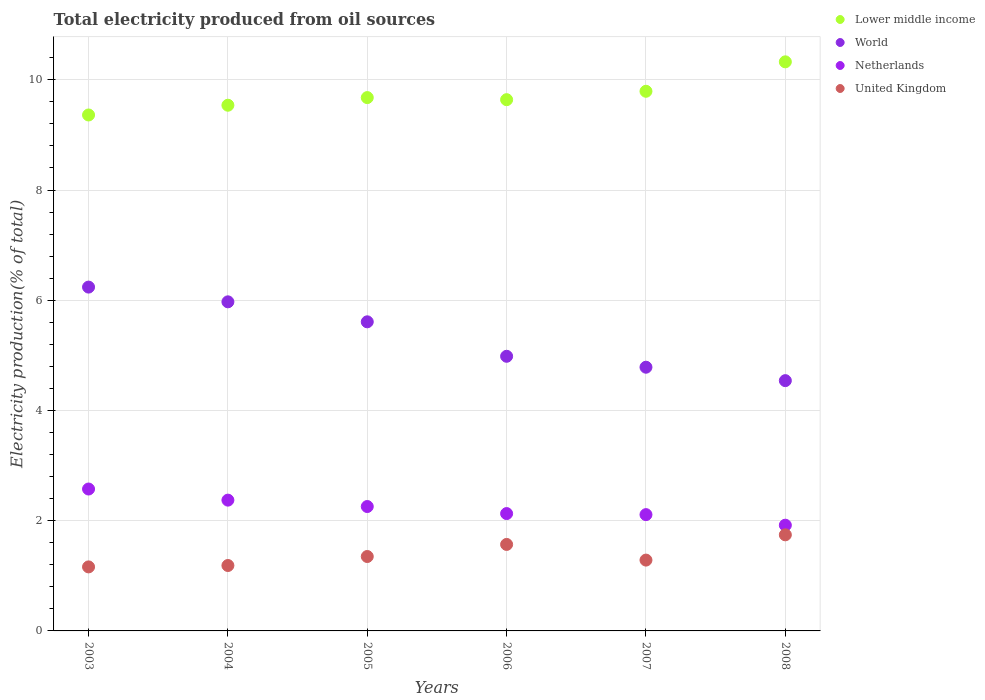How many different coloured dotlines are there?
Ensure brevity in your answer.  4. Is the number of dotlines equal to the number of legend labels?
Your response must be concise. Yes. What is the total electricity produced in World in 2006?
Keep it short and to the point. 4.98. Across all years, what is the maximum total electricity produced in Lower middle income?
Provide a succinct answer. 10.33. Across all years, what is the minimum total electricity produced in Lower middle income?
Make the answer very short. 9.36. In which year was the total electricity produced in United Kingdom maximum?
Offer a terse response. 2008. What is the total total electricity produced in Lower middle income in the graph?
Provide a short and direct response. 58.33. What is the difference between the total electricity produced in Netherlands in 2004 and that in 2005?
Make the answer very short. 0.12. What is the difference between the total electricity produced in Netherlands in 2006 and the total electricity produced in World in 2007?
Give a very brief answer. -2.66. What is the average total electricity produced in World per year?
Provide a succinct answer. 5.35. In the year 2006, what is the difference between the total electricity produced in Lower middle income and total electricity produced in Netherlands?
Your answer should be compact. 7.51. What is the ratio of the total electricity produced in Lower middle income in 2004 to that in 2007?
Your answer should be compact. 0.97. Is the total electricity produced in United Kingdom in 2003 less than that in 2004?
Offer a very short reply. Yes. Is the difference between the total electricity produced in Lower middle income in 2006 and 2008 greater than the difference between the total electricity produced in Netherlands in 2006 and 2008?
Your answer should be very brief. No. What is the difference between the highest and the second highest total electricity produced in World?
Provide a short and direct response. 0.27. What is the difference between the highest and the lowest total electricity produced in Lower middle income?
Offer a very short reply. 0.96. Is it the case that in every year, the sum of the total electricity produced in United Kingdom and total electricity produced in Lower middle income  is greater than the sum of total electricity produced in World and total electricity produced in Netherlands?
Give a very brief answer. Yes. Does the total electricity produced in United Kingdom monotonically increase over the years?
Your answer should be very brief. No. How many dotlines are there?
Offer a terse response. 4. How many years are there in the graph?
Ensure brevity in your answer.  6. What is the difference between two consecutive major ticks on the Y-axis?
Your answer should be compact. 2. Are the values on the major ticks of Y-axis written in scientific E-notation?
Your response must be concise. No. Does the graph contain any zero values?
Make the answer very short. No. Does the graph contain grids?
Your answer should be compact. Yes. Where does the legend appear in the graph?
Your answer should be compact. Top right. How are the legend labels stacked?
Provide a short and direct response. Vertical. What is the title of the graph?
Your response must be concise. Total electricity produced from oil sources. Does "Benin" appear as one of the legend labels in the graph?
Your answer should be very brief. No. What is the Electricity production(% of total) of Lower middle income in 2003?
Your answer should be very brief. 9.36. What is the Electricity production(% of total) of World in 2003?
Make the answer very short. 6.24. What is the Electricity production(% of total) of Netherlands in 2003?
Provide a short and direct response. 2.57. What is the Electricity production(% of total) of United Kingdom in 2003?
Make the answer very short. 1.16. What is the Electricity production(% of total) in Lower middle income in 2004?
Give a very brief answer. 9.54. What is the Electricity production(% of total) in World in 2004?
Ensure brevity in your answer.  5.97. What is the Electricity production(% of total) of Netherlands in 2004?
Your answer should be very brief. 2.37. What is the Electricity production(% of total) in United Kingdom in 2004?
Provide a short and direct response. 1.19. What is the Electricity production(% of total) in Lower middle income in 2005?
Your answer should be very brief. 9.68. What is the Electricity production(% of total) of World in 2005?
Offer a terse response. 5.61. What is the Electricity production(% of total) of Netherlands in 2005?
Ensure brevity in your answer.  2.26. What is the Electricity production(% of total) in United Kingdom in 2005?
Keep it short and to the point. 1.35. What is the Electricity production(% of total) in Lower middle income in 2006?
Offer a very short reply. 9.64. What is the Electricity production(% of total) of World in 2006?
Your response must be concise. 4.98. What is the Electricity production(% of total) in Netherlands in 2006?
Give a very brief answer. 2.13. What is the Electricity production(% of total) in United Kingdom in 2006?
Provide a succinct answer. 1.57. What is the Electricity production(% of total) in Lower middle income in 2007?
Offer a very short reply. 9.79. What is the Electricity production(% of total) in World in 2007?
Offer a terse response. 4.78. What is the Electricity production(% of total) in Netherlands in 2007?
Keep it short and to the point. 2.11. What is the Electricity production(% of total) in United Kingdom in 2007?
Offer a very short reply. 1.29. What is the Electricity production(% of total) of Lower middle income in 2008?
Your answer should be compact. 10.33. What is the Electricity production(% of total) of World in 2008?
Ensure brevity in your answer.  4.54. What is the Electricity production(% of total) in Netherlands in 2008?
Make the answer very short. 1.92. What is the Electricity production(% of total) in United Kingdom in 2008?
Your answer should be very brief. 1.74. Across all years, what is the maximum Electricity production(% of total) of Lower middle income?
Make the answer very short. 10.33. Across all years, what is the maximum Electricity production(% of total) in World?
Offer a terse response. 6.24. Across all years, what is the maximum Electricity production(% of total) of Netherlands?
Ensure brevity in your answer.  2.57. Across all years, what is the maximum Electricity production(% of total) of United Kingdom?
Make the answer very short. 1.74. Across all years, what is the minimum Electricity production(% of total) of Lower middle income?
Keep it short and to the point. 9.36. Across all years, what is the minimum Electricity production(% of total) of World?
Offer a terse response. 4.54. Across all years, what is the minimum Electricity production(% of total) of Netherlands?
Your answer should be compact. 1.92. Across all years, what is the minimum Electricity production(% of total) in United Kingdom?
Ensure brevity in your answer.  1.16. What is the total Electricity production(% of total) in Lower middle income in the graph?
Your response must be concise. 58.33. What is the total Electricity production(% of total) in World in the graph?
Your response must be concise. 32.13. What is the total Electricity production(% of total) of Netherlands in the graph?
Make the answer very short. 13.36. What is the total Electricity production(% of total) in United Kingdom in the graph?
Your response must be concise. 8.3. What is the difference between the Electricity production(% of total) of Lower middle income in 2003 and that in 2004?
Offer a terse response. -0.18. What is the difference between the Electricity production(% of total) in World in 2003 and that in 2004?
Offer a terse response. 0.27. What is the difference between the Electricity production(% of total) in Netherlands in 2003 and that in 2004?
Your answer should be very brief. 0.2. What is the difference between the Electricity production(% of total) in United Kingdom in 2003 and that in 2004?
Make the answer very short. -0.03. What is the difference between the Electricity production(% of total) of Lower middle income in 2003 and that in 2005?
Your answer should be compact. -0.32. What is the difference between the Electricity production(% of total) of World in 2003 and that in 2005?
Ensure brevity in your answer.  0.63. What is the difference between the Electricity production(% of total) in Netherlands in 2003 and that in 2005?
Offer a very short reply. 0.32. What is the difference between the Electricity production(% of total) of United Kingdom in 2003 and that in 2005?
Give a very brief answer. -0.19. What is the difference between the Electricity production(% of total) in Lower middle income in 2003 and that in 2006?
Your response must be concise. -0.28. What is the difference between the Electricity production(% of total) of World in 2003 and that in 2006?
Keep it short and to the point. 1.26. What is the difference between the Electricity production(% of total) in Netherlands in 2003 and that in 2006?
Ensure brevity in your answer.  0.45. What is the difference between the Electricity production(% of total) of United Kingdom in 2003 and that in 2006?
Your answer should be very brief. -0.41. What is the difference between the Electricity production(% of total) of Lower middle income in 2003 and that in 2007?
Offer a terse response. -0.43. What is the difference between the Electricity production(% of total) in World in 2003 and that in 2007?
Provide a succinct answer. 1.45. What is the difference between the Electricity production(% of total) in Netherlands in 2003 and that in 2007?
Give a very brief answer. 0.46. What is the difference between the Electricity production(% of total) of United Kingdom in 2003 and that in 2007?
Provide a short and direct response. -0.12. What is the difference between the Electricity production(% of total) in Lower middle income in 2003 and that in 2008?
Your answer should be compact. -0.96. What is the difference between the Electricity production(% of total) of World in 2003 and that in 2008?
Offer a terse response. 1.7. What is the difference between the Electricity production(% of total) of Netherlands in 2003 and that in 2008?
Ensure brevity in your answer.  0.66. What is the difference between the Electricity production(% of total) in United Kingdom in 2003 and that in 2008?
Make the answer very short. -0.58. What is the difference between the Electricity production(% of total) of Lower middle income in 2004 and that in 2005?
Your answer should be compact. -0.14. What is the difference between the Electricity production(% of total) of World in 2004 and that in 2005?
Provide a succinct answer. 0.36. What is the difference between the Electricity production(% of total) in Netherlands in 2004 and that in 2005?
Provide a succinct answer. 0.12. What is the difference between the Electricity production(% of total) in United Kingdom in 2004 and that in 2005?
Make the answer very short. -0.16. What is the difference between the Electricity production(% of total) in Lower middle income in 2004 and that in 2006?
Give a very brief answer. -0.1. What is the difference between the Electricity production(% of total) of World in 2004 and that in 2006?
Offer a terse response. 0.99. What is the difference between the Electricity production(% of total) in Netherlands in 2004 and that in 2006?
Provide a short and direct response. 0.24. What is the difference between the Electricity production(% of total) in United Kingdom in 2004 and that in 2006?
Keep it short and to the point. -0.38. What is the difference between the Electricity production(% of total) in Lower middle income in 2004 and that in 2007?
Make the answer very short. -0.25. What is the difference between the Electricity production(% of total) in World in 2004 and that in 2007?
Ensure brevity in your answer.  1.19. What is the difference between the Electricity production(% of total) in Netherlands in 2004 and that in 2007?
Provide a short and direct response. 0.26. What is the difference between the Electricity production(% of total) in United Kingdom in 2004 and that in 2007?
Your response must be concise. -0.1. What is the difference between the Electricity production(% of total) of Lower middle income in 2004 and that in 2008?
Your response must be concise. -0.79. What is the difference between the Electricity production(% of total) in World in 2004 and that in 2008?
Your answer should be very brief. 1.43. What is the difference between the Electricity production(% of total) in Netherlands in 2004 and that in 2008?
Offer a terse response. 0.45. What is the difference between the Electricity production(% of total) in United Kingdom in 2004 and that in 2008?
Make the answer very short. -0.56. What is the difference between the Electricity production(% of total) in Lower middle income in 2005 and that in 2006?
Provide a short and direct response. 0.04. What is the difference between the Electricity production(% of total) of World in 2005 and that in 2006?
Offer a very short reply. 0.63. What is the difference between the Electricity production(% of total) in Netherlands in 2005 and that in 2006?
Ensure brevity in your answer.  0.13. What is the difference between the Electricity production(% of total) in United Kingdom in 2005 and that in 2006?
Your answer should be compact. -0.22. What is the difference between the Electricity production(% of total) of Lower middle income in 2005 and that in 2007?
Make the answer very short. -0.11. What is the difference between the Electricity production(% of total) of World in 2005 and that in 2007?
Give a very brief answer. 0.82. What is the difference between the Electricity production(% of total) of Netherlands in 2005 and that in 2007?
Provide a short and direct response. 0.15. What is the difference between the Electricity production(% of total) in United Kingdom in 2005 and that in 2007?
Offer a very short reply. 0.07. What is the difference between the Electricity production(% of total) in Lower middle income in 2005 and that in 2008?
Offer a very short reply. -0.65. What is the difference between the Electricity production(% of total) of World in 2005 and that in 2008?
Your answer should be very brief. 1.07. What is the difference between the Electricity production(% of total) in Netherlands in 2005 and that in 2008?
Your response must be concise. 0.34. What is the difference between the Electricity production(% of total) of United Kingdom in 2005 and that in 2008?
Provide a succinct answer. -0.39. What is the difference between the Electricity production(% of total) of Lower middle income in 2006 and that in 2007?
Provide a succinct answer. -0.15. What is the difference between the Electricity production(% of total) in World in 2006 and that in 2007?
Keep it short and to the point. 0.2. What is the difference between the Electricity production(% of total) in Netherlands in 2006 and that in 2007?
Offer a terse response. 0.02. What is the difference between the Electricity production(% of total) of United Kingdom in 2006 and that in 2007?
Your answer should be very brief. 0.28. What is the difference between the Electricity production(% of total) in Lower middle income in 2006 and that in 2008?
Provide a short and direct response. -0.69. What is the difference between the Electricity production(% of total) in World in 2006 and that in 2008?
Give a very brief answer. 0.44. What is the difference between the Electricity production(% of total) in Netherlands in 2006 and that in 2008?
Give a very brief answer. 0.21. What is the difference between the Electricity production(% of total) in United Kingdom in 2006 and that in 2008?
Provide a succinct answer. -0.17. What is the difference between the Electricity production(% of total) in Lower middle income in 2007 and that in 2008?
Provide a short and direct response. -0.53. What is the difference between the Electricity production(% of total) of World in 2007 and that in 2008?
Provide a short and direct response. 0.24. What is the difference between the Electricity production(% of total) in Netherlands in 2007 and that in 2008?
Provide a succinct answer. 0.19. What is the difference between the Electricity production(% of total) of United Kingdom in 2007 and that in 2008?
Your answer should be compact. -0.46. What is the difference between the Electricity production(% of total) of Lower middle income in 2003 and the Electricity production(% of total) of World in 2004?
Provide a succinct answer. 3.39. What is the difference between the Electricity production(% of total) in Lower middle income in 2003 and the Electricity production(% of total) in Netherlands in 2004?
Offer a very short reply. 6.99. What is the difference between the Electricity production(% of total) in Lower middle income in 2003 and the Electricity production(% of total) in United Kingdom in 2004?
Make the answer very short. 8.17. What is the difference between the Electricity production(% of total) in World in 2003 and the Electricity production(% of total) in Netherlands in 2004?
Your answer should be very brief. 3.87. What is the difference between the Electricity production(% of total) in World in 2003 and the Electricity production(% of total) in United Kingdom in 2004?
Offer a very short reply. 5.05. What is the difference between the Electricity production(% of total) in Netherlands in 2003 and the Electricity production(% of total) in United Kingdom in 2004?
Give a very brief answer. 1.39. What is the difference between the Electricity production(% of total) of Lower middle income in 2003 and the Electricity production(% of total) of World in 2005?
Give a very brief answer. 3.75. What is the difference between the Electricity production(% of total) in Lower middle income in 2003 and the Electricity production(% of total) in Netherlands in 2005?
Offer a terse response. 7.1. What is the difference between the Electricity production(% of total) in Lower middle income in 2003 and the Electricity production(% of total) in United Kingdom in 2005?
Provide a succinct answer. 8.01. What is the difference between the Electricity production(% of total) of World in 2003 and the Electricity production(% of total) of Netherlands in 2005?
Keep it short and to the point. 3.98. What is the difference between the Electricity production(% of total) of World in 2003 and the Electricity production(% of total) of United Kingdom in 2005?
Your answer should be very brief. 4.89. What is the difference between the Electricity production(% of total) of Netherlands in 2003 and the Electricity production(% of total) of United Kingdom in 2005?
Provide a succinct answer. 1.22. What is the difference between the Electricity production(% of total) in Lower middle income in 2003 and the Electricity production(% of total) in World in 2006?
Offer a very short reply. 4.38. What is the difference between the Electricity production(% of total) of Lower middle income in 2003 and the Electricity production(% of total) of Netherlands in 2006?
Ensure brevity in your answer.  7.23. What is the difference between the Electricity production(% of total) in Lower middle income in 2003 and the Electricity production(% of total) in United Kingdom in 2006?
Offer a very short reply. 7.79. What is the difference between the Electricity production(% of total) in World in 2003 and the Electricity production(% of total) in Netherlands in 2006?
Your answer should be compact. 4.11. What is the difference between the Electricity production(% of total) of World in 2003 and the Electricity production(% of total) of United Kingdom in 2006?
Your answer should be compact. 4.67. What is the difference between the Electricity production(% of total) in Netherlands in 2003 and the Electricity production(% of total) in United Kingdom in 2006?
Give a very brief answer. 1.01. What is the difference between the Electricity production(% of total) of Lower middle income in 2003 and the Electricity production(% of total) of World in 2007?
Offer a very short reply. 4.58. What is the difference between the Electricity production(% of total) of Lower middle income in 2003 and the Electricity production(% of total) of Netherlands in 2007?
Your answer should be very brief. 7.25. What is the difference between the Electricity production(% of total) in Lower middle income in 2003 and the Electricity production(% of total) in United Kingdom in 2007?
Offer a terse response. 8.08. What is the difference between the Electricity production(% of total) of World in 2003 and the Electricity production(% of total) of Netherlands in 2007?
Make the answer very short. 4.13. What is the difference between the Electricity production(% of total) of World in 2003 and the Electricity production(% of total) of United Kingdom in 2007?
Provide a succinct answer. 4.95. What is the difference between the Electricity production(% of total) in Netherlands in 2003 and the Electricity production(% of total) in United Kingdom in 2007?
Provide a short and direct response. 1.29. What is the difference between the Electricity production(% of total) in Lower middle income in 2003 and the Electricity production(% of total) in World in 2008?
Your response must be concise. 4.82. What is the difference between the Electricity production(% of total) in Lower middle income in 2003 and the Electricity production(% of total) in Netherlands in 2008?
Offer a very short reply. 7.44. What is the difference between the Electricity production(% of total) in Lower middle income in 2003 and the Electricity production(% of total) in United Kingdom in 2008?
Offer a terse response. 7.62. What is the difference between the Electricity production(% of total) in World in 2003 and the Electricity production(% of total) in Netherlands in 2008?
Ensure brevity in your answer.  4.32. What is the difference between the Electricity production(% of total) in World in 2003 and the Electricity production(% of total) in United Kingdom in 2008?
Your answer should be very brief. 4.49. What is the difference between the Electricity production(% of total) in Netherlands in 2003 and the Electricity production(% of total) in United Kingdom in 2008?
Make the answer very short. 0.83. What is the difference between the Electricity production(% of total) in Lower middle income in 2004 and the Electricity production(% of total) in World in 2005?
Provide a short and direct response. 3.93. What is the difference between the Electricity production(% of total) in Lower middle income in 2004 and the Electricity production(% of total) in Netherlands in 2005?
Offer a terse response. 7.28. What is the difference between the Electricity production(% of total) of Lower middle income in 2004 and the Electricity production(% of total) of United Kingdom in 2005?
Provide a short and direct response. 8.19. What is the difference between the Electricity production(% of total) in World in 2004 and the Electricity production(% of total) in Netherlands in 2005?
Your answer should be very brief. 3.71. What is the difference between the Electricity production(% of total) of World in 2004 and the Electricity production(% of total) of United Kingdom in 2005?
Ensure brevity in your answer.  4.62. What is the difference between the Electricity production(% of total) of Netherlands in 2004 and the Electricity production(% of total) of United Kingdom in 2005?
Your response must be concise. 1.02. What is the difference between the Electricity production(% of total) of Lower middle income in 2004 and the Electricity production(% of total) of World in 2006?
Provide a succinct answer. 4.56. What is the difference between the Electricity production(% of total) in Lower middle income in 2004 and the Electricity production(% of total) in Netherlands in 2006?
Make the answer very short. 7.41. What is the difference between the Electricity production(% of total) of Lower middle income in 2004 and the Electricity production(% of total) of United Kingdom in 2006?
Make the answer very short. 7.97. What is the difference between the Electricity production(% of total) of World in 2004 and the Electricity production(% of total) of Netherlands in 2006?
Ensure brevity in your answer.  3.84. What is the difference between the Electricity production(% of total) in World in 2004 and the Electricity production(% of total) in United Kingdom in 2006?
Provide a short and direct response. 4.4. What is the difference between the Electricity production(% of total) in Netherlands in 2004 and the Electricity production(% of total) in United Kingdom in 2006?
Offer a very short reply. 0.8. What is the difference between the Electricity production(% of total) of Lower middle income in 2004 and the Electricity production(% of total) of World in 2007?
Offer a very short reply. 4.75. What is the difference between the Electricity production(% of total) in Lower middle income in 2004 and the Electricity production(% of total) in Netherlands in 2007?
Keep it short and to the point. 7.43. What is the difference between the Electricity production(% of total) of Lower middle income in 2004 and the Electricity production(% of total) of United Kingdom in 2007?
Ensure brevity in your answer.  8.25. What is the difference between the Electricity production(% of total) in World in 2004 and the Electricity production(% of total) in Netherlands in 2007?
Your response must be concise. 3.86. What is the difference between the Electricity production(% of total) in World in 2004 and the Electricity production(% of total) in United Kingdom in 2007?
Your answer should be compact. 4.69. What is the difference between the Electricity production(% of total) of Netherlands in 2004 and the Electricity production(% of total) of United Kingdom in 2007?
Keep it short and to the point. 1.09. What is the difference between the Electricity production(% of total) in Lower middle income in 2004 and the Electricity production(% of total) in World in 2008?
Provide a short and direct response. 5. What is the difference between the Electricity production(% of total) of Lower middle income in 2004 and the Electricity production(% of total) of Netherlands in 2008?
Make the answer very short. 7.62. What is the difference between the Electricity production(% of total) of Lower middle income in 2004 and the Electricity production(% of total) of United Kingdom in 2008?
Provide a succinct answer. 7.79. What is the difference between the Electricity production(% of total) of World in 2004 and the Electricity production(% of total) of Netherlands in 2008?
Ensure brevity in your answer.  4.05. What is the difference between the Electricity production(% of total) in World in 2004 and the Electricity production(% of total) in United Kingdom in 2008?
Give a very brief answer. 4.23. What is the difference between the Electricity production(% of total) in Netherlands in 2004 and the Electricity production(% of total) in United Kingdom in 2008?
Offer a terse response. 0.63. What is the difference between the Electricity production(% of total) in Lower middle income in 2005 and the Electricity production(% of total) in World in 2006?
Give a very brief answer. 4.69. What is the difference between the Electricity production(% of total) of Lower middle income in 2005 and the Electricity production(% of total) of Netherlands in 2006?
Ensure brevity in your answer.  7.55. What is the difference between the Electricity production(% of total) of Lower middle income in 2005 and the Electricity production(% of total) of United Kingdom in 2006?
Offer a terse response. 8.11. What is the difference between the Electricity production(% of total) of World in 2005 and the Electricity production(% of total) of Netherlands in 2006?
Provide a short and direct response. 3.48. What is the difference between the Electricity production(% of total) of World in 2005 and the Electricity production(% of total) of United Kingdom in 2006?
Provide a short and direct response. 4.04. What is the difference between the Electricity production(% of total) in Netherlands in 2005 and the Electricity production(% of total) in United Kingdom in 2006?
Offer a terse response. 0.69. What is the difference between the Electricity production(% of total) in Lower middle income in 2005 and the Electricity production(% of total) in World in 2007?
Your response must be concise. 4.89. What is the difference between the Electricity production(% of total) of Lower middle income in 2005 and the Electricity production(% of total) of Netherlands in 2007?
Provide a short and direct response. 7.57. What is the difference between the Electricity production(% of total) in Lower middle income in 2005 and the Electricity production(% of total) in United Kingdom in 2007?
Your response must be concise. 8.39. What is the difference between the Electricity production(% of total) of World in 2005 and the Electricity production(% of total) of Netherlands in 2007?
Your response must be concise. 3.5. What is the difference between the Electricity production(% of total) in World in 2005 and the Electricity production(% of total) in United Kingdom in 2007?
Provide a short and direct response. 4.32. What is the difference between the Electricity production(% of total) of Netherlands in 2005 and the Electricity production(% of total) of United Kingdom in 2007?
Provide a succinct answer. 0.97. What is the difference between the Electricity production(% of total) in Lower middle income in 2005 and the Electricity production(% of total) in World in 2008?
Your answer should be compact. 5.14. What is the difference between the Electricity production(% of total) of Lower middle income in 2005 and the Electricity production(% of total) of Netherlands in 2008?
Offer a very short reply. 7.76. What is the difference between the Electricity production(% of total) of Lower middle income in 2005 and the Electricity production(% of total) of United Kingdom in 2008?
Provide a short and direct response. 7.93. What is the difference between the Electricity production(% of total) in World in 2005 and the Electricity production(% of total) in Netherlands in 2008?
Your response must be concise. 3.69. What is the difference between the Electricity production(% of total) of World in 2005 and the Electricity production(% of total) of United Kingdom in 2008?
Keep it short and to the point. 3.87. What is the difference between the Electricity production(% of total) of Netherlands in 2005 and the Electricity production(% of total) of United Kingdom in 2008?
Offer a very short reply. 0.51. What is the difference between the Electricity production(% of total) of Lower middle income in 2006 and the Electricity production(% of total) of World in 2007?
Your response must be concise. 4.85. What is the difference between the Electricity production(% of total) of Lower middle income in 2006 and the Electricity production(% of total) of Netherlands in 2007?
Keep it short and to the point. 7.53. What is the difference between the Electricity production(% of total) in Lower middle income in 2006 and the Electricity production(% of total) in United Kingdom in 2007?
Provide a short and direct response. 8.35. What is the difference between the Electricity production(% of total) in World in 2006 and the Electricity production(% of total) in Netherlands in 2007?
Give a very brief answer. 2.87. What is the difference between the Electricity production(% of total) in World in 2006 and the Electricity production(% of total) in United Kingdom in 2007?
Ensure brevity in your answer.  3.7. What is the difference between the Electricity production(% of total) of Netherlands in 2006 and the Electricity production(% of total) of United Kingdom in 2007?
Provide a succinct answer. 0.84. What is the difference between the Electricity production(% of total) of Lower middle income in 2006 and the Electricity production(% of total) of World in 2008?
Provide a succinct answer. 5.1. What is the difference between the Electricity production(% of total) of Lower middle income in 2006 and the Electricity production(% of total) of Netherlands in 2008?
Keep it short and to the point. 7.72. What is the difference between the Electricity production(% of total) of Lower middle income in 2006 and the Electricity production(% of total) of United Kingdom in 2008?
Make the answer very short. 7.9. What is the difference between the Electricity production(% of total) in World in 2006 and the Electricity production(% of total) in Netherlands in 2008?
Offer a very short reply. 3.06. What is the difference between the Electricity production(% of total) in World in 2006 and the Electricity production(% of total) in United Kingdom in 2008?
Provide a short and direct response. 3.24. What is the difference between the Electricity production(% of total) in Netherlands in 2006 and the Electricity production(% of total) in United Kingdom in 2008?
Keep it short and to the point. 0.39. What is the difference between the Electricity production(% of total) in Lower middle income in 2007 and the Electricity production(% of total) in World in 2008?
Your answer should be very brief. 5.25. What is the difference between the Electricity production(% of total) of Lower middle income in 2007 and the Electricity production(% of total) of Netherlands in 2008?
Give a very brief answer. 7.87. What is the difference between the Electricity production(% of total) in Lower middle income in 2007 and the Electricity production(% of total) in United Kingdom in 2008?
Offer a terse response. 8.05. What is the difference between the Electricity production(% of total) in World in 2007 and the Electricity production(% of total) in Netherlands in 2008?
Ensure brevity in your answer.  2.87. What is the difference between the Electricity production(% of total) of World in 2007 and the Electricity production(% of total) of United Kingdom in 2008?
Offer a terse response. 3.04. What is the difference between the Electricity production(% of total) of Netherlands in 2007 and the Electricity production(% of total) of United Kingdom in 2008?
Ensure brevity in your answer.  0.37. What is the average Electricity production(% of total) in Lower middle income per year?
Ensure brevity in your answer.  9.72. What is the average Electricity production(% of total) in World per year?
Your answer should be compact. 5.35. What is the average Electricity production(% of total) in Netherlands per year?
Provide a short and direct response. 2.23. What is the average Electricity production(% of total) in United Kingdom per year?
Offer a terse response. 1.38. In the year 2003, what is the difference between the Electricity production(% of total) of Lower middle income and Electricity production(% of total) of World?
Your response must be concise. 3.12. In the year 2003, what is the difference between the Electricity production(% of total) in Lower middle income and Electricity production(% of total) in Netherlands?
Provide a short and direct response. 6.79. In the year 2003, what is the difference between the Electricity production(% of total) of Lower middle income and Electricity production(% of total) of United Kingdom?
Your answer should be very brief. 8.2. In the year 2003, what is the difference between the Electricity production(% of total) of World and Electricity production(% of total) of Netherlands?
Your response must be concise. 3.66. In the year 2003, what is the difference between the Electricity production(% of total) in World and Electricity production(% of total) in United Kingdom?
Your response must be concise. 5.08. In the year 2003, what is the difference between the Electricity production(% of total) in Netherlands and Electricity production(% of total) in United Kingdom?
Make the answer very short. 1.41. In the year 2004, what is the difference between the Electricity production(% of total) in Lower middle income and Electricity production(% of total) in World?
Ensure brevity in your answer.  3.57. In the year 2004, what is the difference between the Electricity production(% of total) of Lower middle income and Electricity production(% of total) of Netherlands?
Offer a terse response. 7.17. In the year 2004, what is the difference between the Electricity production(% of total) of Lower middle income and Electricity production(% of total) of United Kingdom?
Provide a succinct answer. 8.35. In the year 2004, what is the difference between the Electricity production(% of total) of World and Electricity production(% of total) of Netherlands?
Give a very brief answer. 3.6. In the year 2004, what is the difference between the Electricity production(% of total) in World and Electricity production(% of total) in United Kingdom?
Offer a terse response. 4.78. In the year 2004, what is the difference between the Electricity production(% of total) of Netherlands and Electricity production(% of total) of United Kingdom?
Provide a succinct answer. 1.19. In the year 2005, what is the difference between the Electricity production(% of total) in Lower middle income and Electricity production(% of total) in World?
Give a very brief answer. 4.07. In the year 2005, what is the difference between the Electricity production(% of total) in Lower middle income and Electricity production(% of total) in Netherlands?
Keep it short and to the point. 7.42. In the year 2005, what is the difference between the Electricity production(% of total) of Lower middle income and Electricity production(% of total) of United Kingdom?
Provide a short and direct response. 8.33. In the year 2005, what is the difference between the Electricity production(% of total) of World and Electricity production(% of total) of Netherlands?
Provide a succinct answer. 3.35. In the year 2005, what is the difference between the Electricity production(% of total) in World and Electricity production(% of total) in United Kingdom?
Provide a succinct answer. 4.26. In the year 2005, what is the difference between the Electricity production(% of total) of Netherlands and Electricity production(% of total) of United Kingdom?
Provide a short and direct response. 0.91. In the year 2006, what is the difference between the Electricity production(% of total) in Lower middle income and Electricity production(% of total) in World?
Keep it short and to the point. 4.66. In the year 2006, what is the difference between the Electricity production(% of total) of Lower middle income and Electricity production(% of total) of Netherlands?
Keep it short and to the point. 7.51. In the year 2006, what is the difference between the Electricity production(% of total) in Lower middle income and Electricity production(% of total) in United Kingdom?
Offer a terse response. 8.07. In the year 2006, what is the difference between the Electricity production(% of total) in World and Electricity production(% of total) in Netherlands?
Ensure brevity in your answer.  2.85. In the year 2006, what is the difference between the Electricity production(% of total) in World and Electricity production(% of total) in United Kingdom?
Provide a succinct answer. 3.41. In the year 2006, what is the difference between the Electricity production(% of total) in Netherlands and Electricity production(% of total) in United Kingdom?
Your response must be concise. 0.56. In the year 2007, what is the difference between the Electricity production(% of total) in Lower middle income and Electricity production(% of total) in World?
Give a very brief answer. 5.01. In the year 2007, what is the difference between the Electricity production(% of total) in Lower middle income and Electricity production(% of total) in Netherlands?
Offer a terse response. 7.68. In the year 2007, what is the difference between the Electricity production(% of total) of Lower middle income and Electricity production(% of total) of United Kingdom?
Make the answer very short. 8.51. In the year 2007, what is the difference between the Electricity production(% of total) of World and Electricity production(% of total) of Netherlands?
Keep it short and to the point. 2.67. In the year 2007, what is the difference between the Electricity production(% of total) in World and Electricity production(% of total) in United Kingdom?
Ensure brevity in your answer.  3.5. In the year 2007, what is the difference between the Electricity production(% of total) of Netherlands and Electricity production(% of total) of United Kingdom?
Provide a succinct answer. 0.82. In the year 2008, what is the difference between the Electricity production(% of total) in Lower middle income and Electricity production(% of total) in World?
Offer a terse response. 5.78. In the year 2008, what is the difference between the Electricity production(% of total) in Lower middle income and Electricity production(% of total) in Netherlands?
Your answer should be compact. 8.41. In the year 2008, what is the difference between the Electricity production(% of total) of Lower middle income and Electricity production(% of total) of United Kingdom?
Provide a short and direct response. 8.58. In the year 2008, what is the difference between the Electricity production(% of total) of World and Electricity production(% of total) of Netherlands?
Your response must be concise. 2.62. In the year 2008, what is the difference between the Electricity production(% of total) of World and Electricity production(% of total) of United Kingdom?
Provide a short and direct response. 2.8. In the year 2008, what is the difference between the Electricity production(% of total) in Netherlands and Electricity production(% of total) in United Kingdom?
Offer a terse response. 0.17. What is the ratio of the Electricity production(% of total) in Lower middle income in 2003 to that in 2004?
Give a very brief answer. 0.98. What is the ratio of the Electricity production(% of total) of World in 2003 to that in 2004?
Your answer should be compact. 1.04. What is the ratio of the Electricity production(% of total) in Netherlands in 2003 to that in 2004?
Make the answer very short. 1.08. What is the ratio of the Electricity production(% of total) in United Kingdom in 2003 to that in 2004?
Give a very brief answer. 0.98. What is the ratio of the Electricity production(% of total) in Lower middle income in 2003 to that in 2005?
Give a very brief answer. 0.97. What is the ratio of the Electricity production(% of total) of World in 2003 to that in 2005?
Make the answer very short. 1.11. What is the ratio of the Electricity production(% of total) in Netherlands in 2003 to that in 2005?
Give a very brief answer. 1.14. What is the ratio of the Electricity production(% of total) of United Kingdom in 2003 to that in 2005?
Provide a succinct answer. 0.86. What is the ratio of the Electricity production(% of total) in Lower middle income in 2003 to that in 2006?
Give a very brief answer. 0.97. What is the ratio of the Electricity production(% of total) of World in 2003 to that in 2006?
Your response must be concise. 1.25. What is the ratio of the Electricity production(% of total) of Netherlands in 2003 to that in 2006?
Keep it short and to the point. 1.21. What is the ratio of the Electricity production(% of total) in United Kingdom in 2003 to that in 2006?
Make the answer very short. 0.74. What is the ratio of the Electricity production(% of total) in Lower middle income in 2003 to that in 2007?
Ensure brevity in your answer.  0.96. What is the ratio of the Electricity production(% of total) of World in 2003 to that in 2007?
Your answer should be very brief. 1.3. What is the ratio of the Electricity production(% of total) of Netherlands in 2003 to that in 2007?
Your answer should be very brief. 1.22. What is the ratio of the Electricity production(% of total) of United Kingdom in 2003 to that in 2007?
Your answer should be compact. 0.9. What is the ratio of the Electricity production(% of total) in Lower middle income in 2003 to that in 2008?
Keep it short and to the point. 0.91. What is the ratio of the Electricity production(% of total) in World in 2003 to that in 2008?
Your answer should be very brief. 1.37. What is the ratio of the Electricity production(% of total) in Netherlands in 2003 to that in 2008?
Keep it short and to the point. 1.34. What is the ratio of the Electricity production(% of total) in United Kingdom in 2003 to that in 2008?
Your response must be concise. 0.67. What is the ratio of the Electricity production(% of total) of Lower middle income in 2004 to that in 2005?
Offer a terse response. 0.99. What is the ratio of the Electricity production(% of total) in World in 2004 to that in 2005?
Keep it short and to the point. 1.06. What is the ratio of the Electricity production(% of total) in Netherlands in 2004 to that in 2005?
Your answer should be compact. 1.05. What is the ratio of the Electricity production(% of total) in United Kingdom in 2004 to that in 2005?
Make the answer very short. 0.88. What is the ratio of the Electricity production(% of total) of Lower middle income in 2004 to that in 2006?
Your answer should be compact. 0.99. What is the ratio of the Electricity production(% of total) in World in 2004 to that in 2006?
Offer a terse response. 1.2. What is the ratio of the Electricity production(% of total) in Netherlands in 2004 to that in 2006?
Ensure brevity in your answer.  1.11. What is the ratio of the Electricity production(% of total) in United Kingdom in 2004 to that in 2006?
Your answer should be very brief. 0.76. What is the ratio of the Electricity production(% of total) of Lower middle income in 2004 to that in 2007?
Your answer should be compact. 0.97. What is the ratio of the Electricity production(% of total) of World in 2004 to that in 2007?
Ensure brevity in your answer.  1.25. What is the ratio of the Electricity production(% of total) of Netherlands in 2004 to that in 2007?
Your answer should be compact. 1.12. What is the ratio of the Electricity production(% of total) in United Kingdom in 2004 to that in 2007?
Keep it short and to the point. 0.92. What is the ratio of the Electricity production(% of total) of Lower middle income in 2004 to that in 2008?
Offer a terse response. 0.92. What is the ratio of the Electricity production(% of total) of World in 2004 to that in 2008?
Offer a terse response. 1.31. What is the ratio of the Electricity production(% of total) in Netherlands in 2004 to that in 2008?
Keep it short and to the point. 1.24. What is the ratio of the Electricity production(% of total) of United Kingdom in 2004 to that in 2008?
Ensure brevity in your answer.  0.68. What is the ratio of the Electricity production(% of total) in World in 2005 to that in 2006?
Your answer should be compact. 1.13. What is the ratio of the Electricity production(% of total) in Netherlands in 2005 to that in 2006?
Ensure brevity in your answer.  1.06. What is the ratio of the Electricity production(% of total) of United Kingdom in 2005 to that in 2006?
Offer a very short reply. 0.86. What is the ratio of the Electricity production(% of total) of Lower middle income in 2005 to that in 2007?
Your response must be concise. 0.99. What is the ratio of the Electricity production(% of total) in World in 2005 to that in 2007?
Ensure brevity in your answer.  1.17. What is the ratio of the Electricity production(% of total) in Netherlands in 2005 to that in 2007?
Make the answer very short. 1.07. What is the ratio of the Electricity production(% of total) in United Kingdom in 2005 to that in 2007?
Offer a terse response. 1.05. What is the ratio of the Electricity production(% of total) of Lower middle income in 2005 to that in 2008?
Your answer should be very brief. 0.94. What is the ratio of the Electricity production(% of total) of World in 2005 to that in 2008?
Your response must be concise. 1.24. What is the ratio of the Electricity production(% of total) in Netherlands in 2005 to that in 2008?
Give a very brief answer. 1.18. What is the ratio of the Electricity production(% of total) in United Kingdom in 2005 to that in 2008?
Provide a succinct answer. 0.77. What is the ratio of the Electricity production(% of total) in Lower middle income in 2006 to that in 2007?
Your response must be concise. 0.98. What is the ratio of the Electricity production(% of total) of World in 2006 to that in 2007?
Keep it short and to the point. 1.04. What is the ratio of the Electricity production(% of total) in Netherlands in 2006 to that in 2007?
Provide a short and direct response. 1.01. What is the ratio of the Electricity production(% of total) of United Kingdom in 2006 to that in 2007?
Your response must be concise. 1.22. What is the ratio of the Electricity production(% of total) in Lower middle income in 2006 to that in 2008?
Make the answer very short. 0.93. What is the ratio of the Electricity production(% of total) in World in 2006 to that in 2008?
Offer a terse response. 1.1. What is the ratio of the Electricity production(% of total) of Netherlands in 2006 to that in 2008?
Offer a terse response. 1.11. What is the ratio of the Electricity production(% of total) in United Kingdom in 2006 to that in 2008?
Your answer should be compact. 0.9. What is the ratio of the Electricity production(% of total) in Lower middle income in 2007 to that in 2008?
Your answer should be very brief. 0.95. What is the ratio of the Electricity production(% of total) of World in 2007 to that in 2008?
Your response must be concise. 1.05. What is the ratio of the Electricity production(% of total) in Netherlands in 2007 to that in 2008?
Keep it short and to the point. 1.1. What is the ratio of the Electricity production(% of total) in United Kingdom in 2007 to that in 2008?
Provide a short and direct response. 0.74. What is the difference between the highest and the second highest Electricity production(% of total) of Lower middle income?
Provide a succinct answer. 0.53. What is the difference between the highest and the second highest Electricity production(% of total) in World?
Your response must be concise. 0.27. What is the difference between the highest and the second highest Electricity production(% of total) in Netherlands?
Ensure brevity in your answer.  0.2. What is the difference between the highest and the second highest Electricity production(% of total) of United Kingdom?
Offer a very short reply. 0.17. What is the difference between the highest and the lowest Electricity production(% of total) in Lower middle income?
Your answer should be very brief. 0.96. What is the difference between the highest and the lowest Electricity production(% of total) in World?
Offer a terse response. 1.7. What is the difference between the highest and the lowest Electricity production(% of total) of Netherlands?
Provide a short and direct response. 0.66. What is the difference between the highest and the lowest Electricity production(% of total) of United Kingdom?
Offer a terse response. 0.58. 